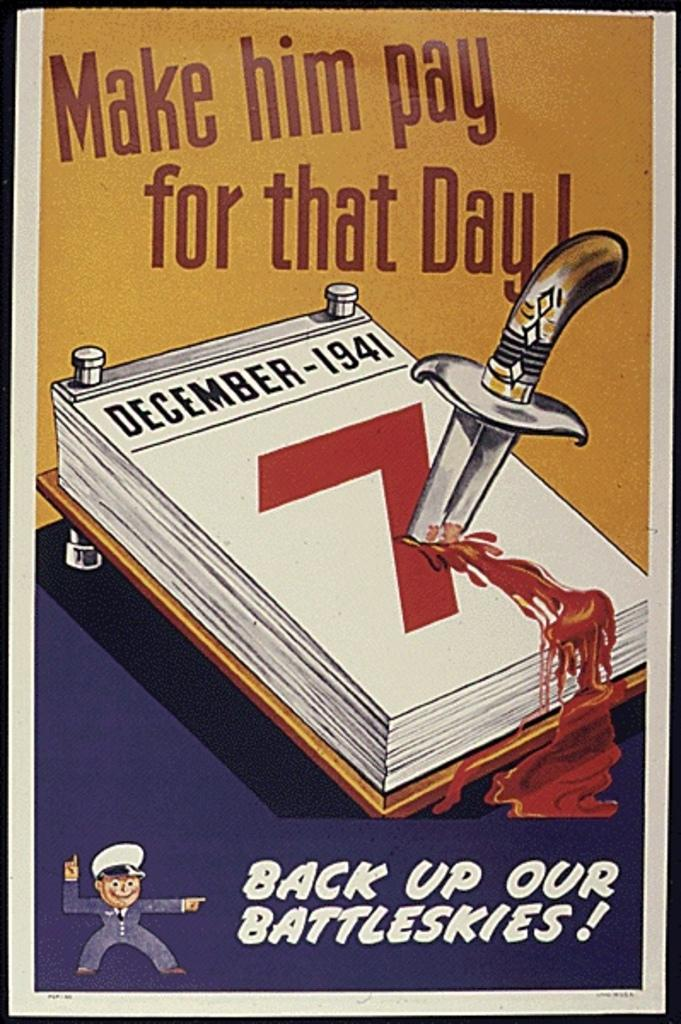What is the main subject in the center of the image? There is a poster in the center of the image. What is depicted on the poster? The poster contains papers, a person, a knife, and an image of blood. Is there any text on the poster? Yes, there is text on the poster. What type of shoe is shown on the poster? There is no shoe depicted on the poster; it features papers, a person, a knife, and an image of blood. What is the purpose of the creature shown on the poster? There is no creature depicted on the poster; it features papers, a person, a knife, and an image of blood. 